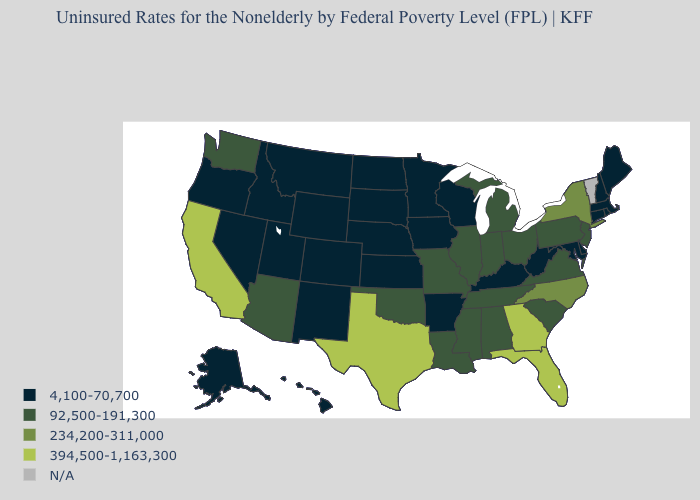What is the highest value in the USA?
Concise answer only. 394,500-1,163,300. Name the states that have a value in the range 234,200-311,000?
Keep it brief. New York, North Carolina. Among the states that border Arizona , which have the highest value?
Concise answer only. California. Name the states that have a value in the range 4,100-70,700?
Be succinct. Alaska, Arkansas, Colorado, Connecticut, Delaware, Hawaii, Idaho, Iowa, Kansas, Kentucky, Maine, Maryland, Massachusetts, Minnesota, Montana, Nebraska, Nevada, New Hampshire, New Mexico, North Dakota, Oregon, Rhode Island, South Dakota, Utah, West Virginia, Wisconsin, Wyoming. What is the value of Arkansas?
Concise answer only. 4,100-70,700. Name the states that have a value in the range 4,100-70,700?
Concise answer only. Alaska, Arkansas, Colorado, Connecticut, Delaware, Hawaii, Idaho, Iowa, Kansas, Kentucky, Maine, Maryland, Massachusetts, Minnesota, Montana, Nebraska, Nevada, New Hampshire, New Mexico, North Dakota, Oregon, Rhode Island, South Dakota, Utah, West Virginia, Wisconsin, Wyoming. Does Missouri have the lowest value in the MidWest?
Keep it brief. No. How many symbols are there in the legend?
Give a very brief answer. 5. How many symbols are there in the legend?
Give a very brief answer. 5. Among the states that border South Dakota , which have the highest value?
Give a very brief answer. Iowa, Minnesota, Montana, Nebraska, North Dakota, Wyoming. Name the states that have a value in the range 394,500-1,163,300?
Keep it brief. California, Florida, Georgia, Texas. Among the states that border Virginia , which have the lowest value?
Write a very short answer. Kentucky, Maryland, West Virginia. What is the value of Kentucky?
Write a very short answer. 4,100-70,700. 